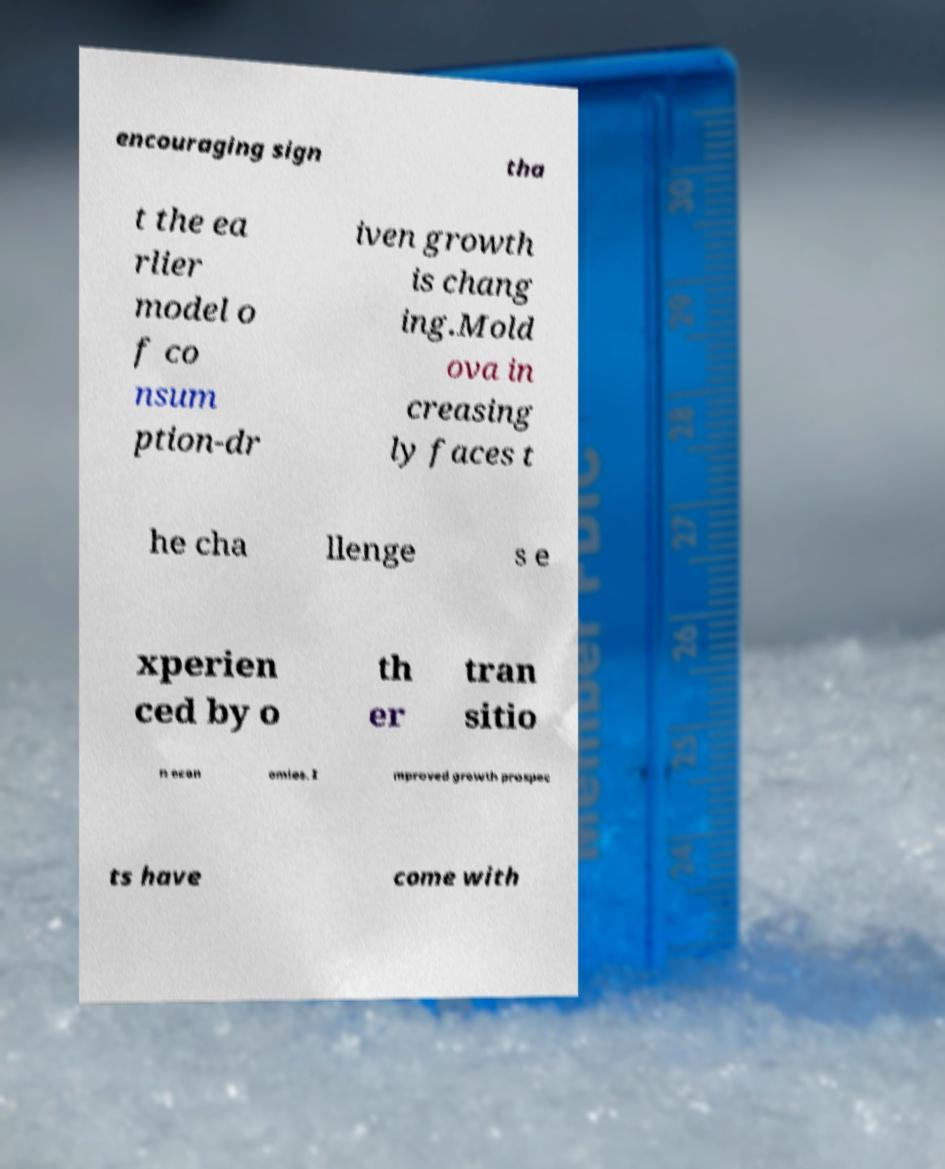Could you extract and type out the text from this image? encouraging sign tha t the ea rlier model o f co nsum ption-dr iven growth is chang ing.Mold ova in creasing ly faces t he cha llenge s e xperien ced by o th er tran sitio n econ omies. I mproved growth prospec ts have come with 